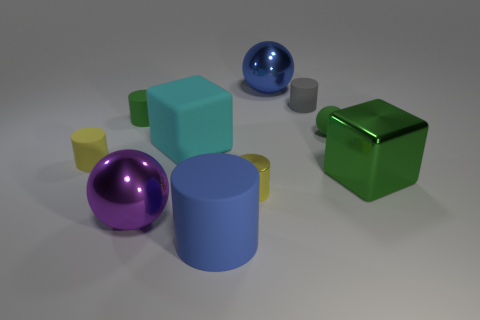Subtract all large metallic spheres. How many spheres are left? 1 Subtract all yellow cylinders. How many cylinders are left? 3 Subtract 1 balls. How many balls are left? 2 Subtract all cyan cylinders. Subtract all gray spheres. How many cylinders are left? 5 Subtract all spheres. How many objects are left? 7 Subtract 1 purple balls. How many objects are left? 9 Subtract all yellow shiny cubes. Subtract all blue cylinders. How many objects are left? 9 Add 4 cubes. How many cubes are left? 6 Add 7 tiny blue metal blocks. How many tiny blue metal blocks exist? 7 